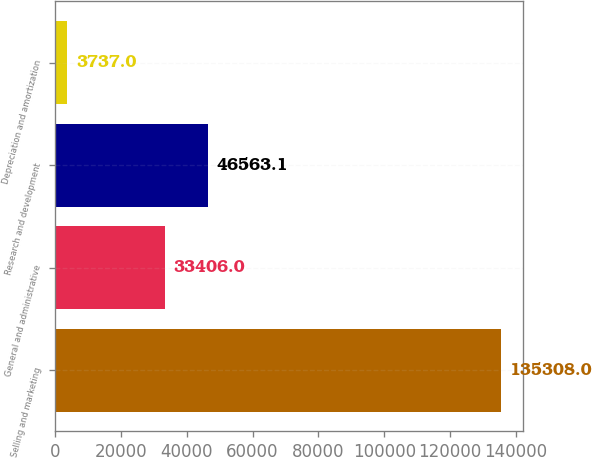Convert chart. <chart><loc_0><loc_0><loc_500><loc_500><bar_chart><fcel>Selling and marketing<fcel>General and administrative<fcel>Research and development<fcel>Depreciation and amortization<nl><fcel>135308<fcel>33406<fcel>46563.1<fcel>3737<nl></chart> 